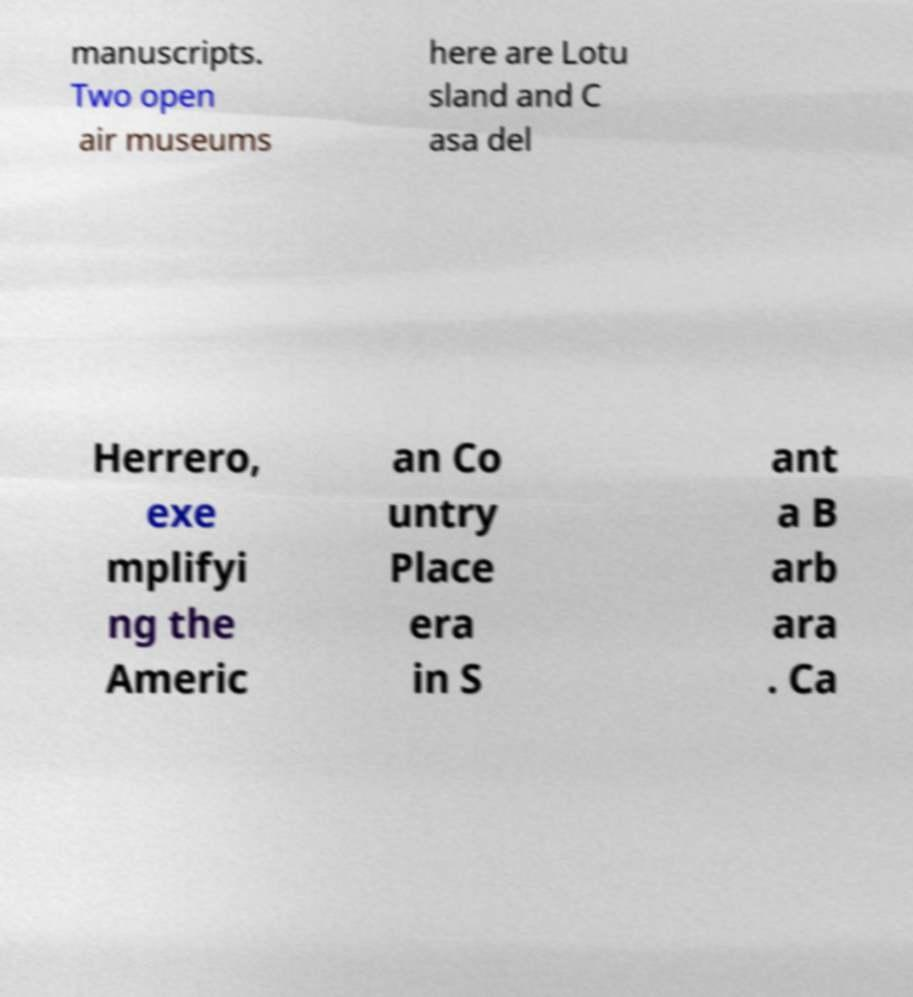Can you read and provide the text displayed in the image?This photo seems to have some interesting text. Can you extract and type it out for me? manuscripts. Two open air museums here are Lotu sland and C asa del Herrero, exe mplifyi ng the Americ an Co untry Place era in S ant a B arb ara . Ca 